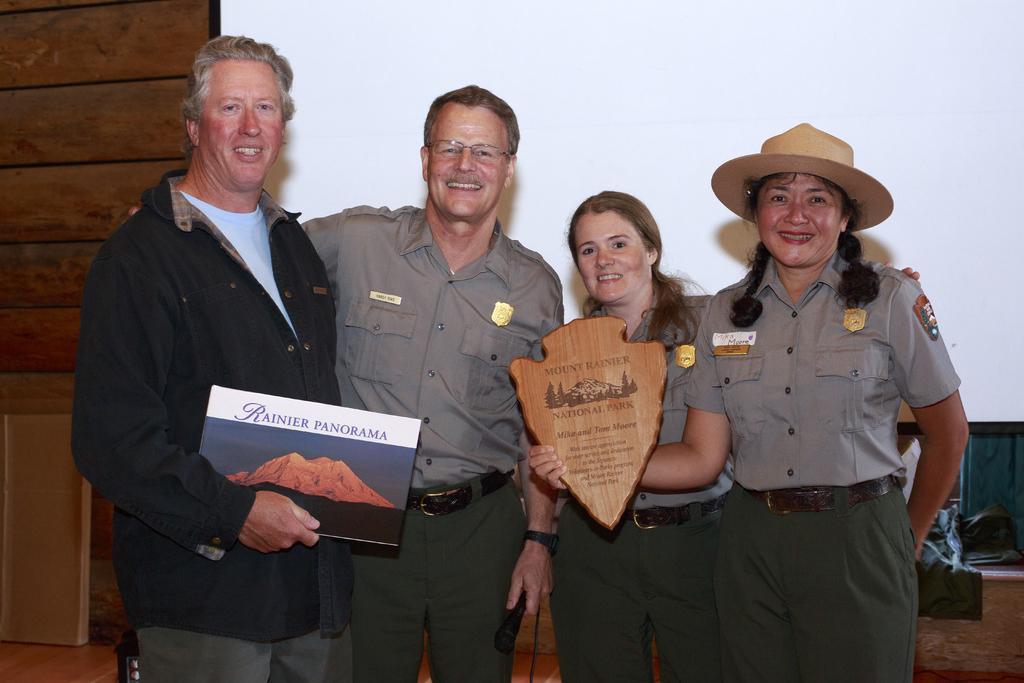Could you give a brief overview of what you see in this image? In this image, we can see people and some are wearing uniforms and holding boards with some text and one of them is wearing a hat. In the background, there are some objects and we can see a cardboard and there is a wall. 